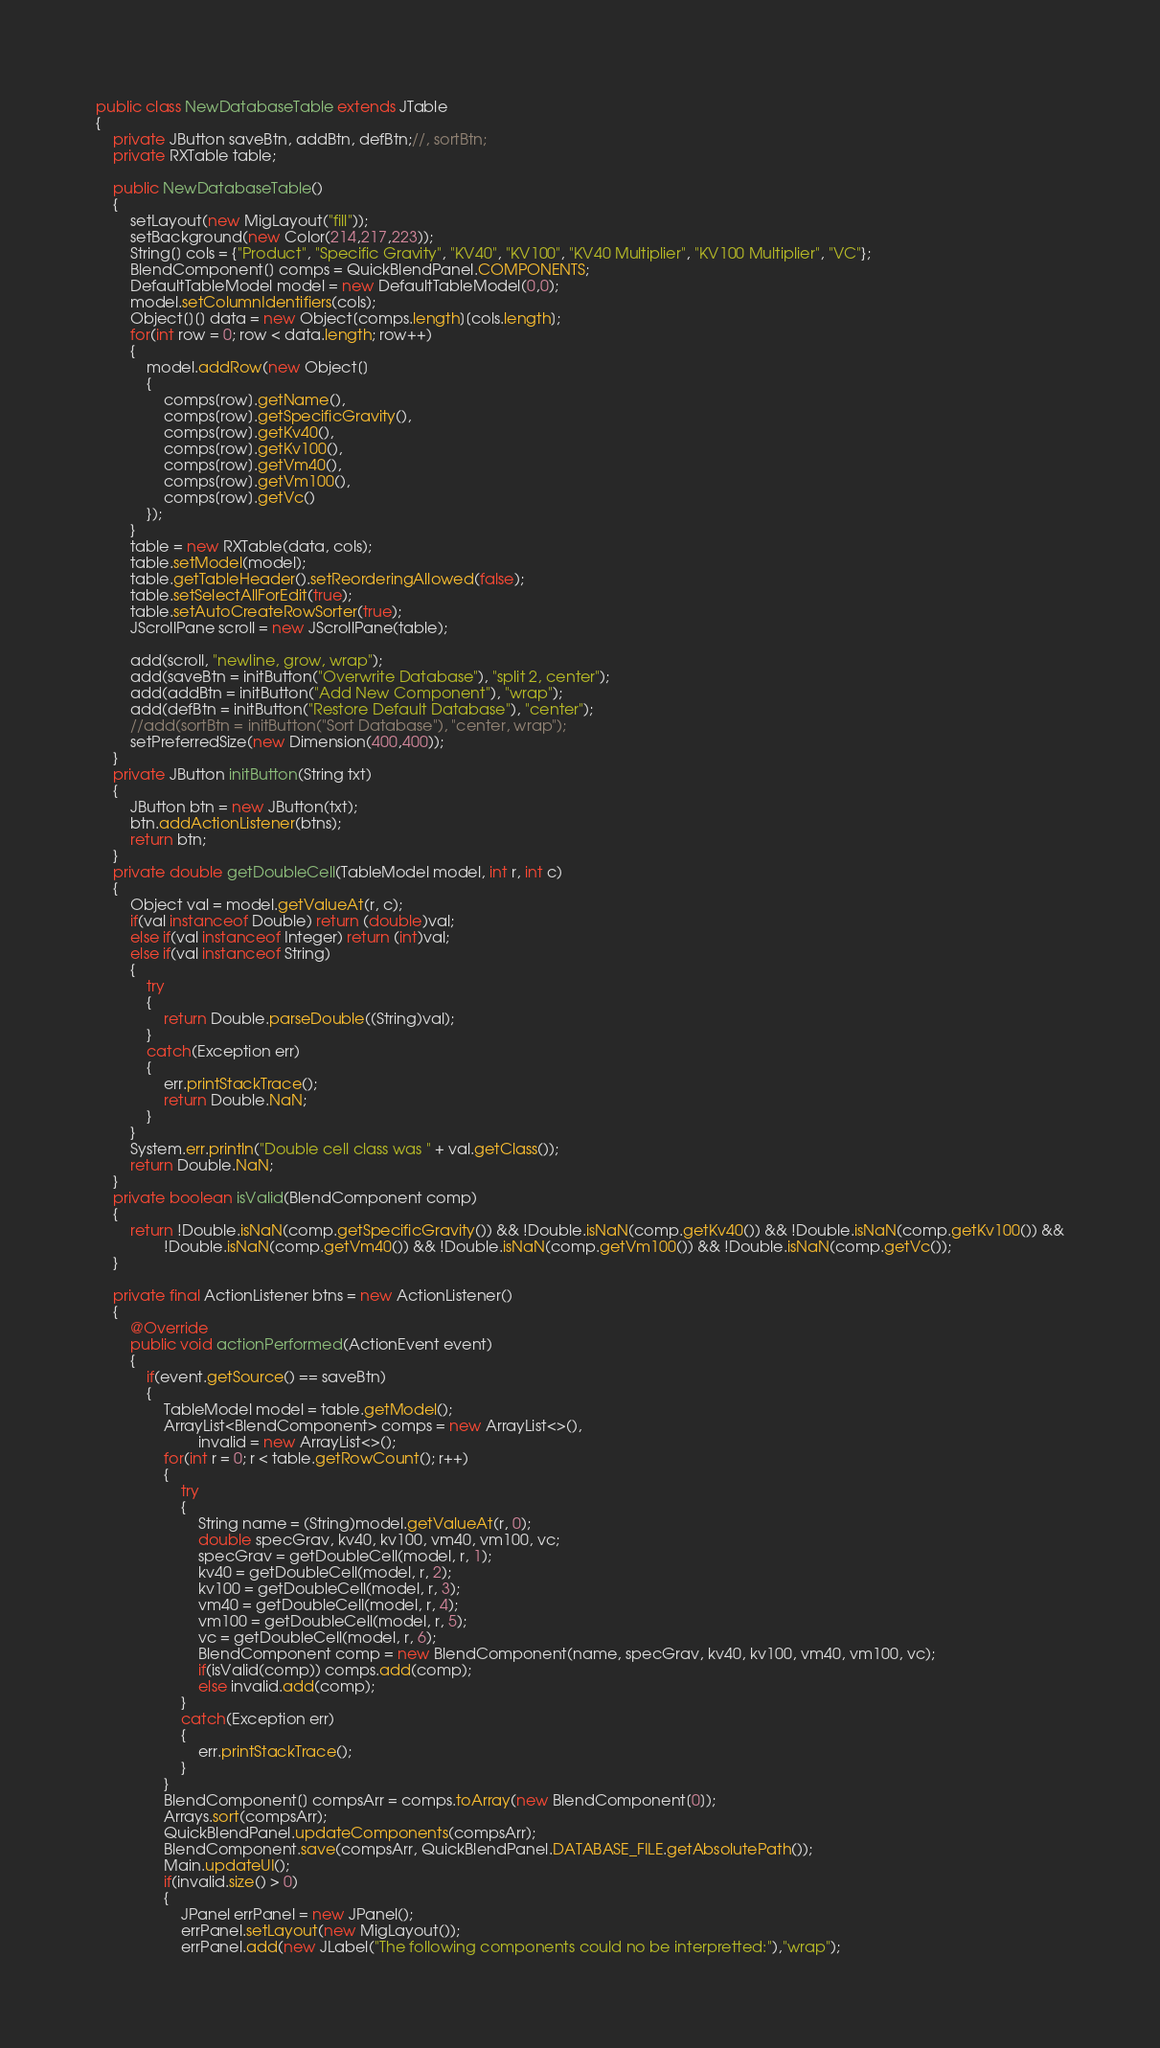<code> <loc_0><loc_0><loc_500><loc_500><_Java_>
public class NewDatabaseTable extends JTable
{
    private JButton saveBtn, addBtn, defBtn;//, sortBtn;
    private RXTable table;
    
    public NewDatabaseTable()
    {
        setLayout(new MigLayout("fill"));
        setBackground(new Color(214,217,223));
        String[] cols = {"Product", "Specific Gravity", "KV40", "KV100", "KV40 Multiplier", "KV100 Multiplier", "VC"};
        BlendComponent[] comps = QuickBlendPanel.COMPONENTS;
        DefaultTableModel model = new DefaultTableModel(0,0);
        model.setColumnIdentifiers(cols);
        Object[][] data = new Object[comps.length][cols.length];
        for(int row = 0; row < data.length; row++)
        {
            model.addRow(new Object[]
            {
                comps[row].getName(),
                comps[row].getSpecificGravity(),
                comps[row].getKv40(),
                comps[row].getKv100(),
                comps[row].getVm40(),
                comps[row].getVm100(),
                comps[row].getVc()
            });
        }
        table = new RXTable(data, cols);
        table.setModel(model);
        table.getTableHeader().setReorderingAllowed(false);
        table.setSelectAllForEdit(true);
        table.setAutoCreateRowSorter(true);
        JScrollPane scroll = new JScrollPane(table);
        
        add(scroll, "newline, grow, wrap");
        add(saveBtn = initButton("Overwrite Database"), "split 2, center");
        add(addBtn = initButton("Add New Component"), "wrap");
        add(defBtn = initButton("Restore Default Database"), "center");
        //add(sortBtn = initButton("Sort Database"), "center, wrap");
        setPreferredSize(new Dimension(400,400));
    }
    private JButton initButton(String txt)
    {
        JButton btn = new JButton(txt);
        btn.addActionListener(btns);
        return btn;
    }
    private double getDoubleCell(TableModel model, int r, int c)
    {
        Object val = model.getValueAt(r, c);
        if(val instanceof Double) return (double)val;
        else if(val instanceof Integer) return (int)val;
        else if(val instanceof String) 
        {
            try
            {
                return Double.parseDouble((String)val);
            }
            catch(Exception err)
            {
                err.printStackTrace();
                return Double.NaN;
            }
        }
        System.err.println("Double cell class was " + val.getClass());
        return Double.NaN;
    }
    private boolean isValid(BlendComponent comp)
    {
        return !Double.isNaN(comp.getSpecificGravity()) && !Double.isNaN(comp.getKv40()) && !Double.isNaN(comp.getKv100()) &&
                !Double.isNaN(comp.getVm40()) && !Double.isNaN(comp.getVm100()) && !Double.isNaN(comp.getVc());
    }
    
    private final ActionListener btns = new ActionListener()
    {
        @Override
        public void actionPerformed(ActionEvent event)
        {
            if(event.getSource() == saveBtn)
            {
                TableModel model = table.getModel();
                ArrayList<BlendComponent> comps = new ArrayList<>(),
                        invalid = new ArrayList<>();
                for(int r = 0; r < table.getRowCount(); r++)
                {
                    try
                    {
                        String name = (String)model.getValueAt(r, 0);
                        double specGrav, kv40, kv100, vm40, vm100, vc;
                        specGrav = getDoubleCell(model, r, 1);
                        kv40 = getDoubleCell(model, r, 2);
                        kv100 = getDoubleCell(model, r, 3);
                        vm40 = getDoubleCell(model, r, 4);
                        vm100 = getDoubleCell(model, r, 5);
                        vc = getDoubleCell(model, r, 6);
                        BlendComponent comp = new BlendComponent(name, specGrav, kv40, kv100, vm40, vm100, vc);
                        if(isValid(comp)) comps.add(comp);
                        else invalid.add(comp);
                    }
                    catch(Exception err)
                    {
                        err.printStackTrace();
                    }
                }
                BlendComponent[] compsArr = comps.toArray(new BlendComponent[0]);
                Arrays.sort(compsArr);
                QuickBlendPanel.updateComponents(compsArr);
                BlendComponent.save(compsArr, QuickBlendPanel.DATABASE_FILE.getAbsolutePath());
                Main.updateUI();
                if(invalid.size() > 0)
                {
                    JPanel errPanel = new JPanel();
                    errPanel.setLayout(new MigLayout());
                    errPanel.add(new JLabel("The following components could no be interpretted:"),"wrap");</code> 